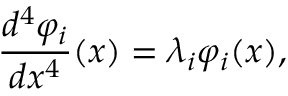Convert formula to latex. <formula><loc_0><loc_0><loc_500><loc_500>\frac { d ^ { 4 } \varphi _ { i } } { d x ^ { 4 } } ( x ) = \lambda _ { i } \varphi _ { i } ( x ) ,</formula> 